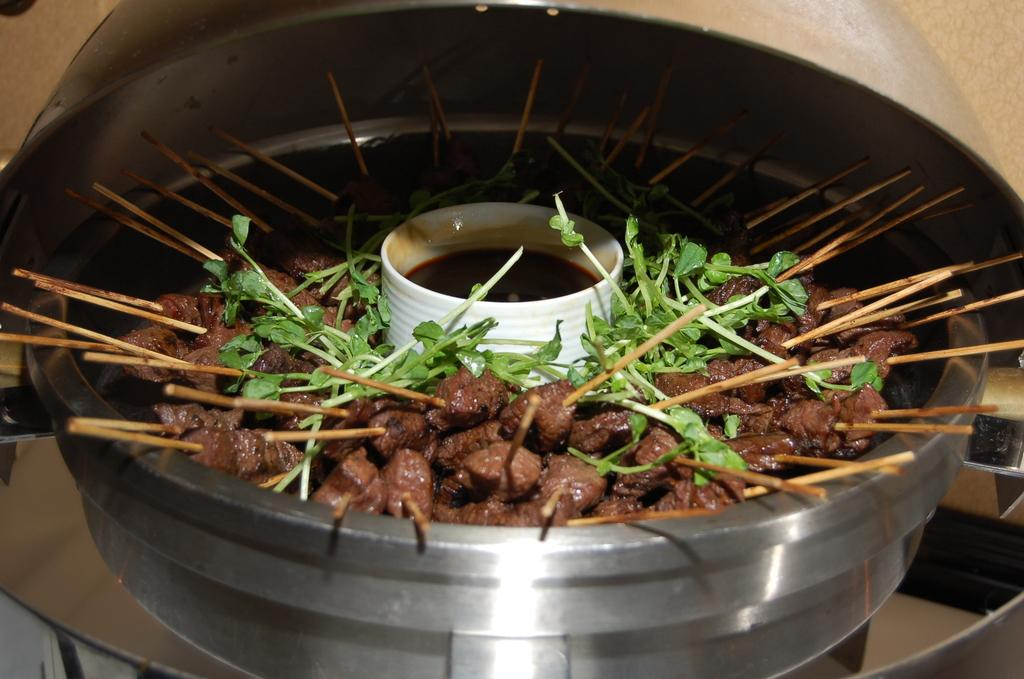What is in the dish that is visible in the image? There is a dish containing cooked food items in the image. How are the food items arranged or connected in the dish? A stick is inserted into each food item in the dish. What is the purpose of the sauce in the image? The sauce is present between the food items and the sticks, likely for dipping or flavoring. What type of plants can be seen growing in harmony with the food items in the image? There are no plants visible in the image, and the food items are not depicted as growing in harmony with any plants. 